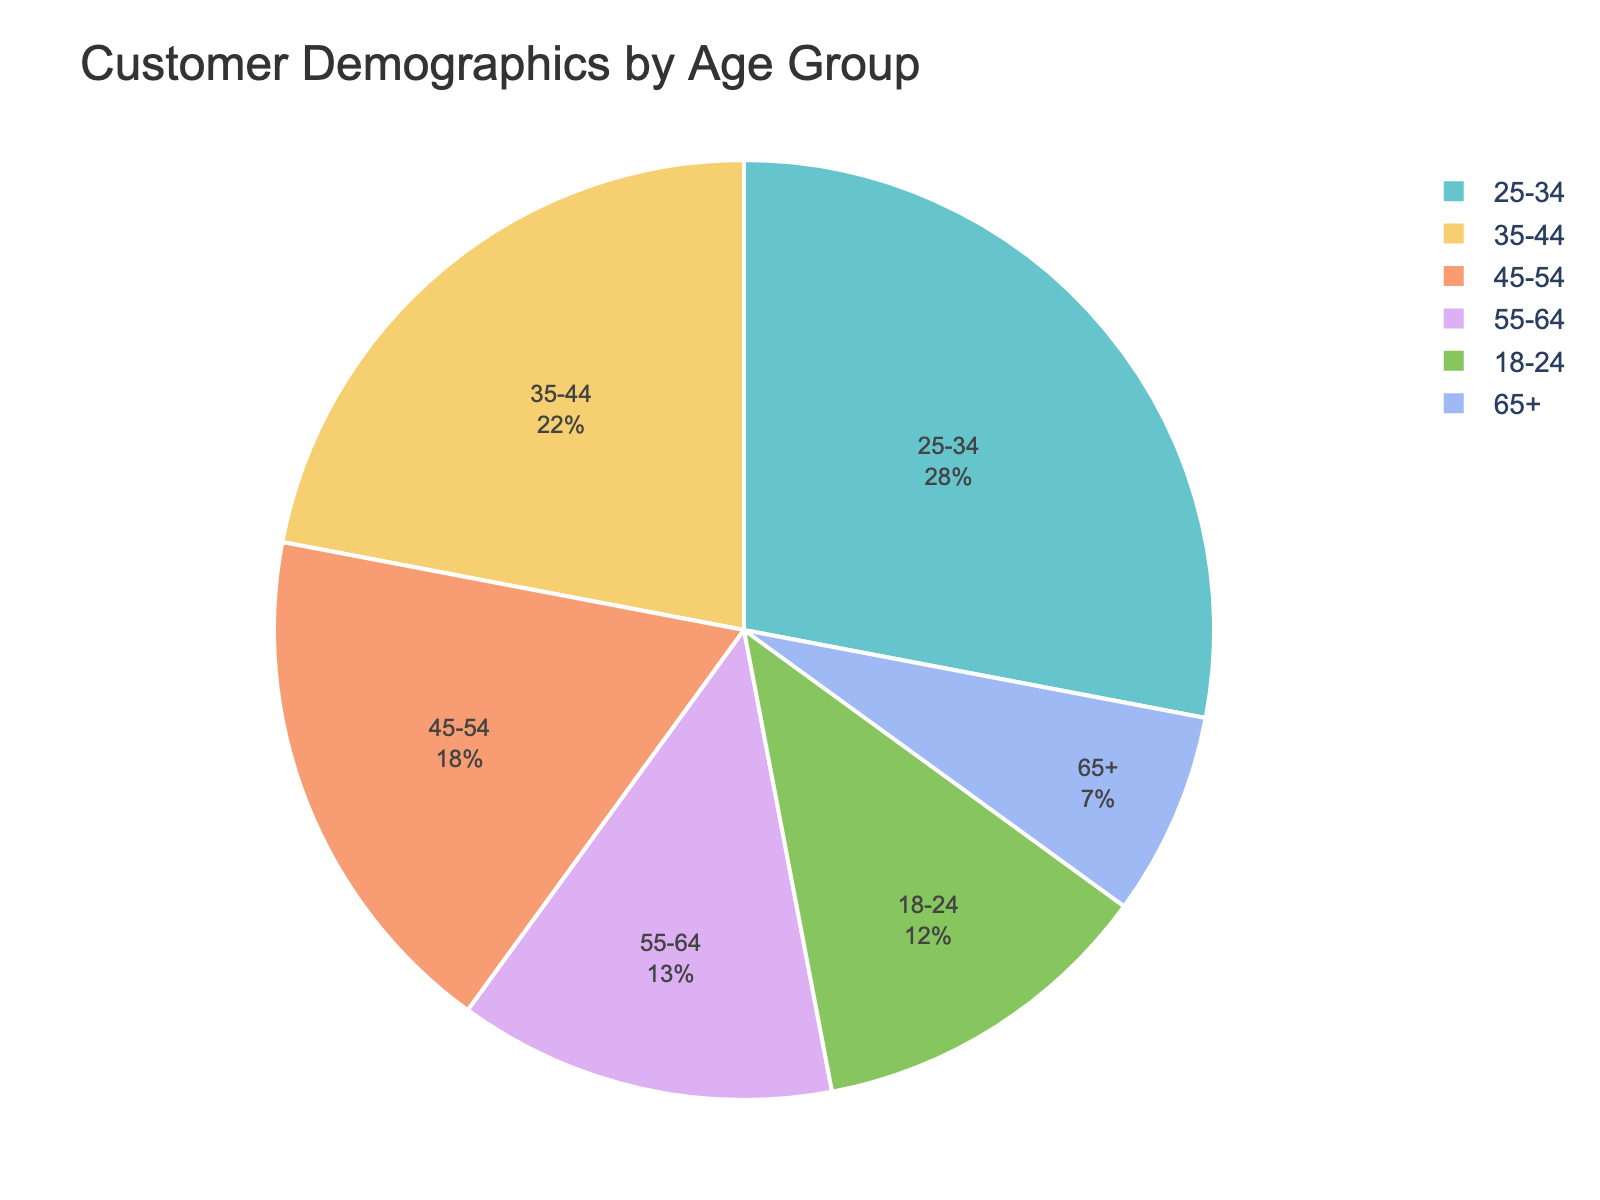What's the largest age group by percentage? The pie chart shows the percentage of customers by age group, and the largest segment visually is labeled 25-34 at 28%.
Answer: 25-34 What's the combined percentage of customers aged 55 and over? Add the percentages for age groups 55-64 (13%) and 65+ (7%). 13% + 7% = 20%.
Answer: 20% Which is larger: the percentage of customers aged 35-44 or those aged 18-24? According to the pie chart, 35-44 is 22% while 18-24 is 12%. Thus, 35-44 is larger.
Answer: 35-44 What is the difference in percentage between the 25-34 and 45-54 age groups? Subtract the percentage of 45-54 (18%) from 25-34 (28%). 28% - 18% = 10%.
Answer: 10% Among the age groups under 35, which segment constitutes the smallest percentage? The pie chart segments under 35 are 18-24 (12%) and 25-34 (28%). The smallest is 18-24 with 12%.
Answer: 18-24 What's the sum of the percentages for customers aged 25-34 and 35-44? Add the percentages of 25-34 (28%) and 35-44 (22%). 28% + 22% = 50%.
Answer: 50% Which two age groups combined exceed the percentage of the 25-34 group alone? The 25-34 age group is 28%. The sum of 18-24 (12%) and 55-64 (13%) is 25%, and adding 65+ (7%) surpasses 28%. So, 18-24, 55-64, and 65+ combined exceed 28%.
Answer: 18-24 and 55-64 Compare the color and position of the segment representing the 65+ age group to those of the 45-54 age group. Observing the chart, the 65+ segment is significantly smaller and has a pastel color, while the 45-54 segment is larger and located next to the 35-44 segment.
Answer: Smaller, pastel color, next to 35-44 Which age group has close to double the percentage of the 65+ age group? The 65+ age group accounts for 7%. The 55-64 age group is almost double at 13%.
Answer: 55-64 